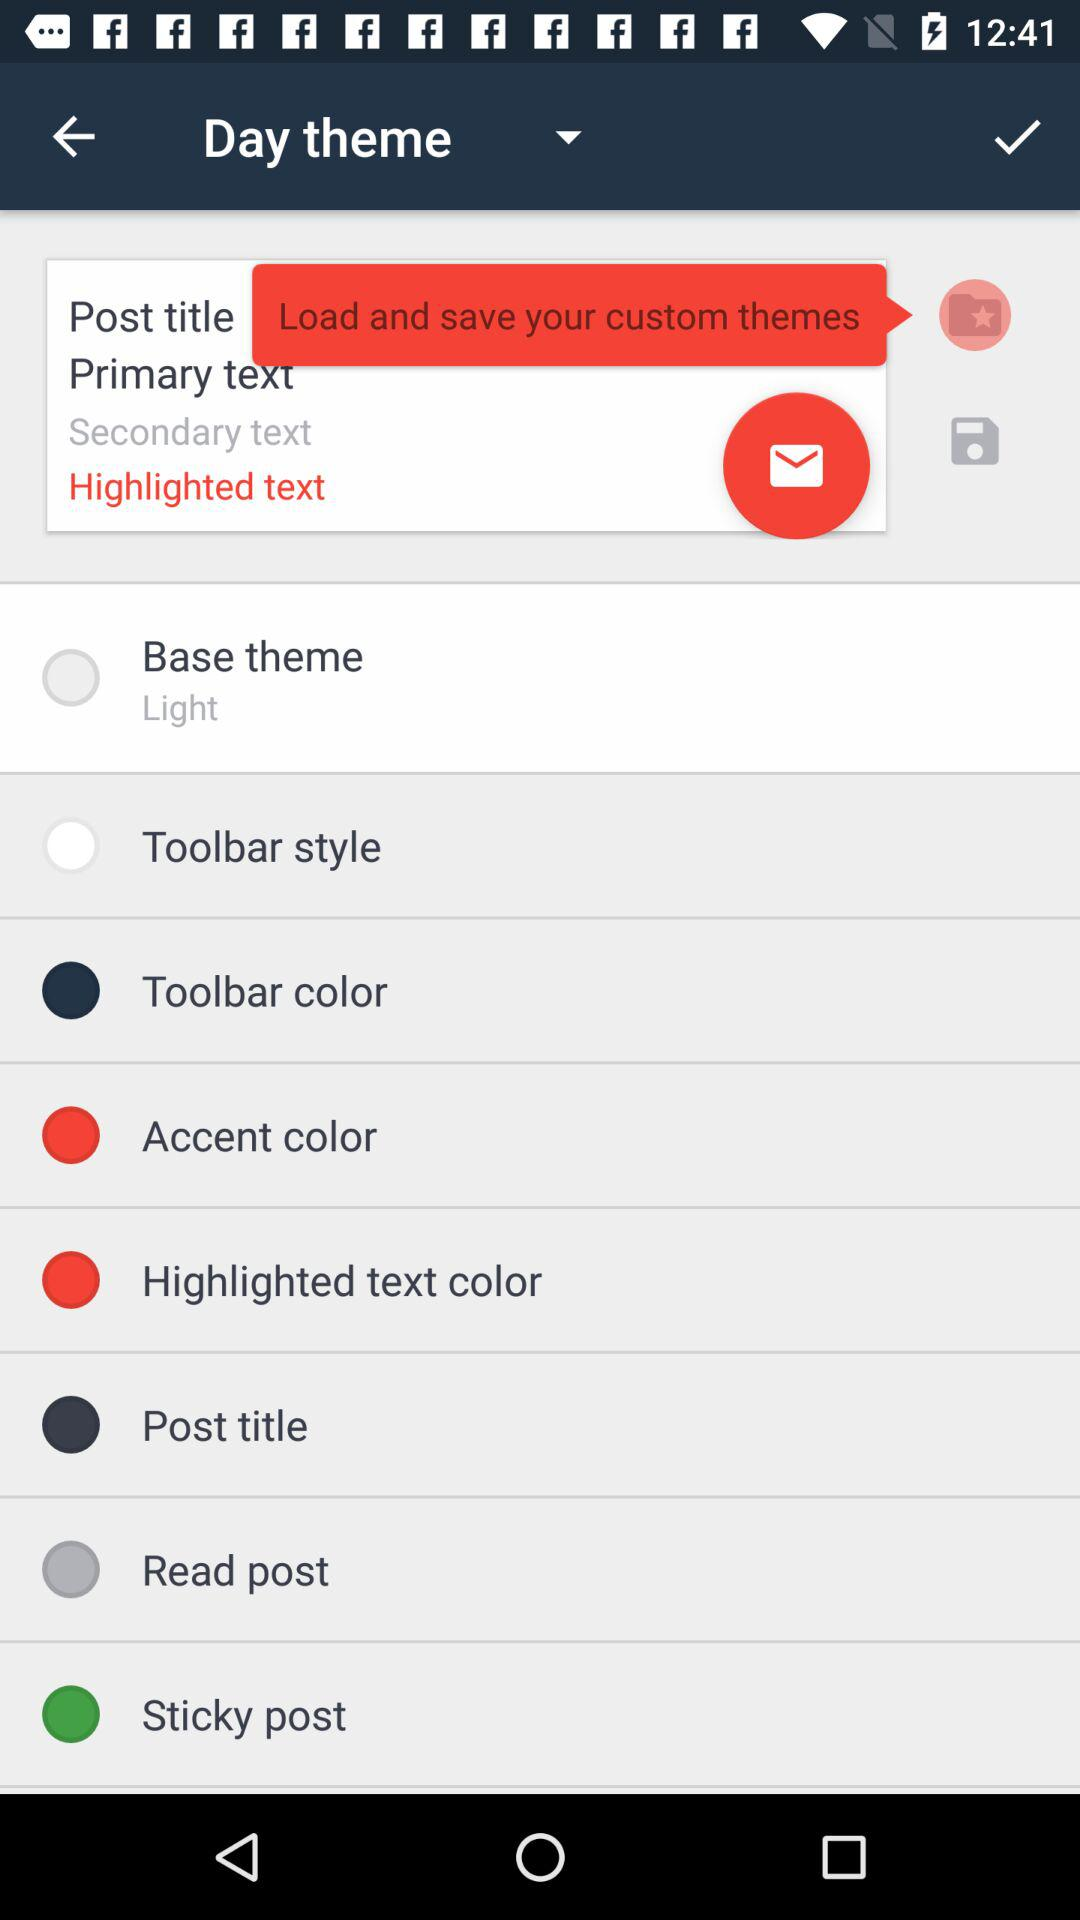What is the base theme? The base theme is "Light". 